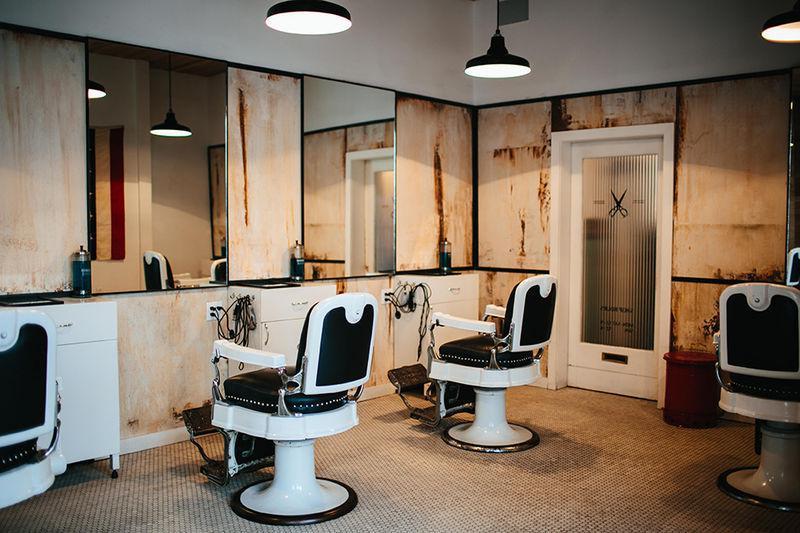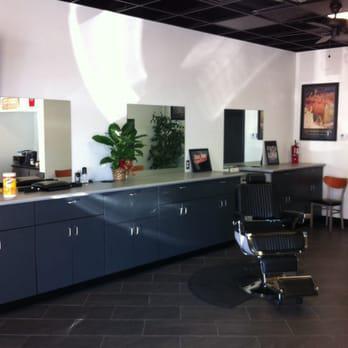The first image is the image on the left, the second image is the image on the right. Given the left and right images, does the statement "Two black, forward facing, barber chairs are in one of the images." hold true? Answer yes or no. No. The first image is the image on the left, the second image is the image on the right. Given the left and right images, does the statement "There is a total of four barber chairs." hold true? Answer yes or no. No. 